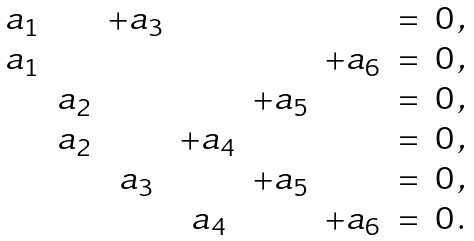<formula> <loc_0><loc_0><loc_500><loc_500>\begin{matrix} a _ { 1 } & & + a _ { 3 } & & & & = & 0 \, , \\ a _ { 1 } & & & & & + a _ { 6 } & = & 0 \, , \\ & a _ { 2 } & & & + a _ { 5 } & & = & 0 \, , \\ & a _ { 2 } & & + a _ { 4 } & & & = & 0 \, , \\ & & a _ { 3 } & & + a _ { 5 } & & = & 0 \, , \\ & & & a _ { 4 } & & + a _ { 6 } & = & 0 \, . \end{matrix}</formula> 